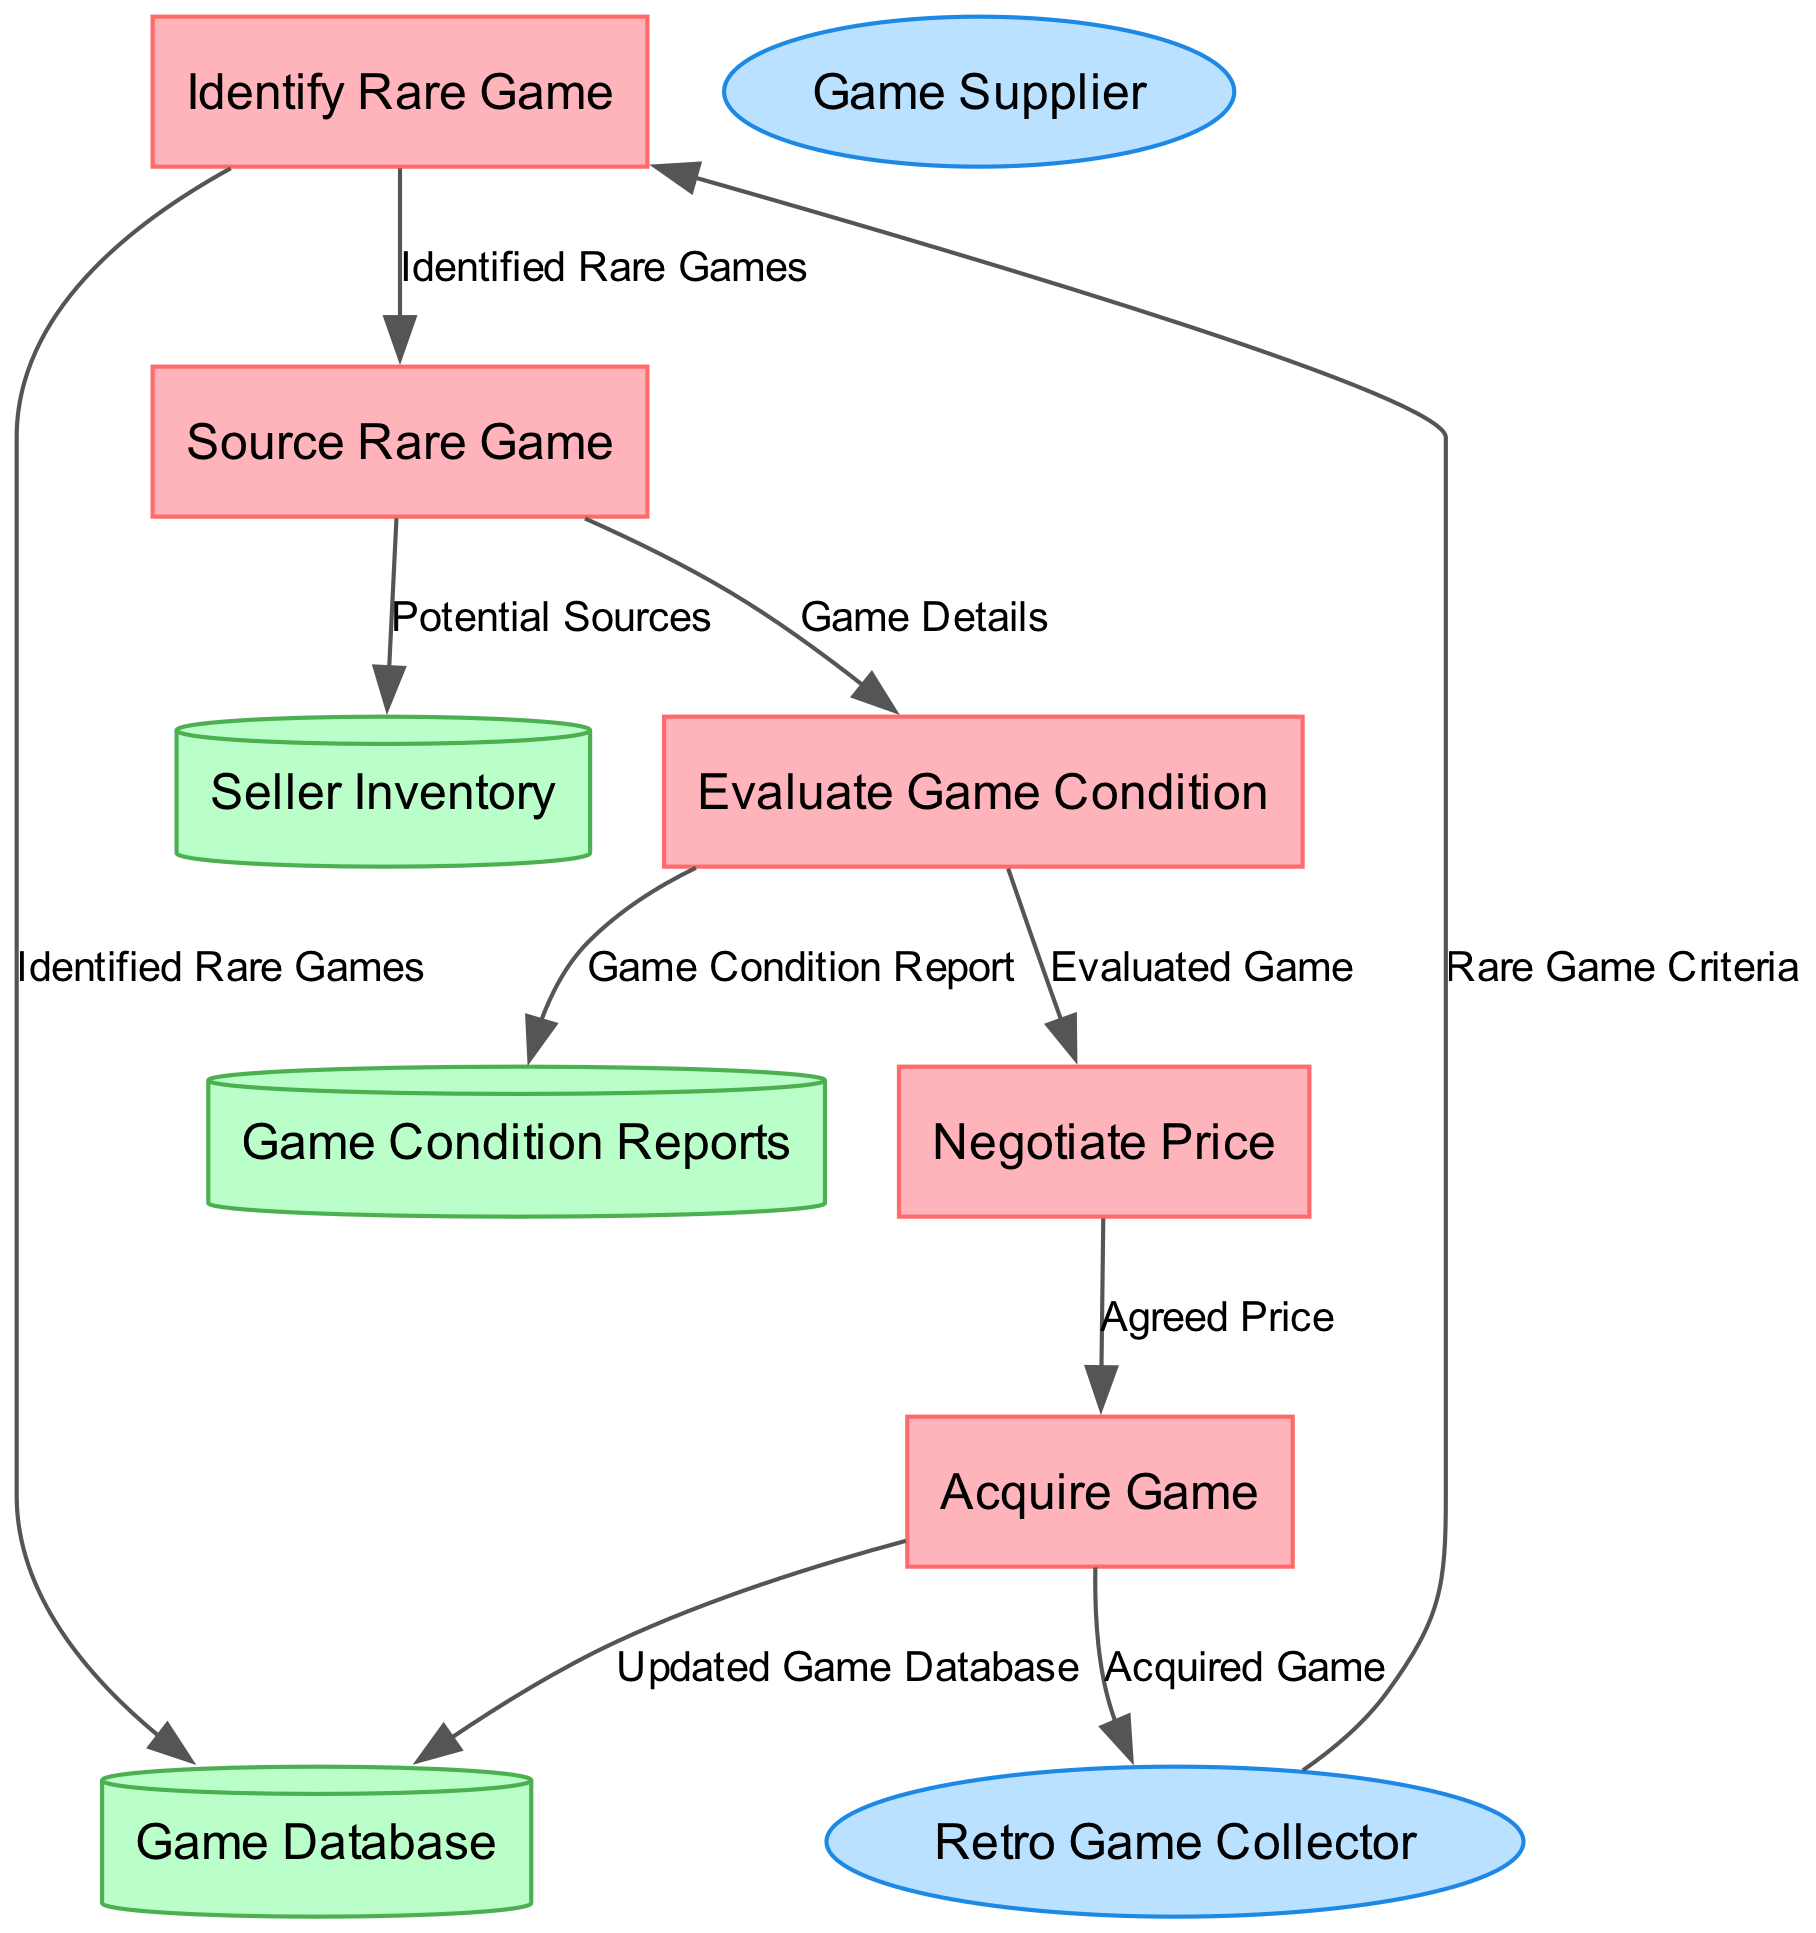What is the first process in the diagram? The diagram clearly identifies the processes, and the first one listed is "Identify Rare Game". Thus, the first process is determined by locating the topmost process node.
Answer: Identify Rare Game How many data stores are present in the diagram? By counting the nodes categorized as data stores, we identify three: "Game Database," "Seller Inventory," and "Game Condition Reports." This requires simply adding the store nodes.
Answer: 3 What data flows from the "Evaluate Game Condition" process? Examining the edges from the "Evaluate Game Condition" process, we see there are two outgoing flows: "Game Condition Report" and "Evaluated Game." Therefore, we check which nodes are directly connected by edges to ascertain the outputs.
Answer: Game Condition Report, Evaluated Game Which external entity provides retro games? The diagram indicates there is an external entity labeled "Game Supplier," which directly indicates a source of retro games. We identify this by looking at the external entities section.
Answer: Game Supplier From which process does the "Identified Rare Games" flow originate? Tracing the data flow, the "Identified Rare Games" is sent from the "Identify Rare Game" process to both the data store and subsequent sourcing process. This involves examining the input/output relations of the processes.
Answer: Identify Rare Game What is the final step in acquiring a rare game? The last step depicted in the flowchart is the "Acquire Game" process, which signifies the completion of the acquisition journey. We determine this by reviewing the process order in the diagram.
Answer: Acquire Game How does "Game Collector" interact with the "Negotiate Price" process? The "Retro Game Collector" provides input to the "Negotiate Price" process through the "Evaluated Game" data flow, meaning their interaction involves negotiation based on the evaluation. This requires tracing the data flow connections from the collector to the process.
Answer: Provides Evaluated Game What type of information is stored in the "Game Database"? The "Game Database" is described as a repository of information on various retro games and their rarity, indicating the nature of the data it contains. This involves checking the data stores section and analyzing their descriptions.
Answer: Information on various retro games and their rarity What agreement leads to the final transaction in acquiring the game? "Agreed Price" is the data flow that leads from the negotiation to the acquisition, meaning this price is critical to finalizing the transaction. We validate this by examining the relationships leading into the "Acquire Game" process.
Answer: Agreed Price 